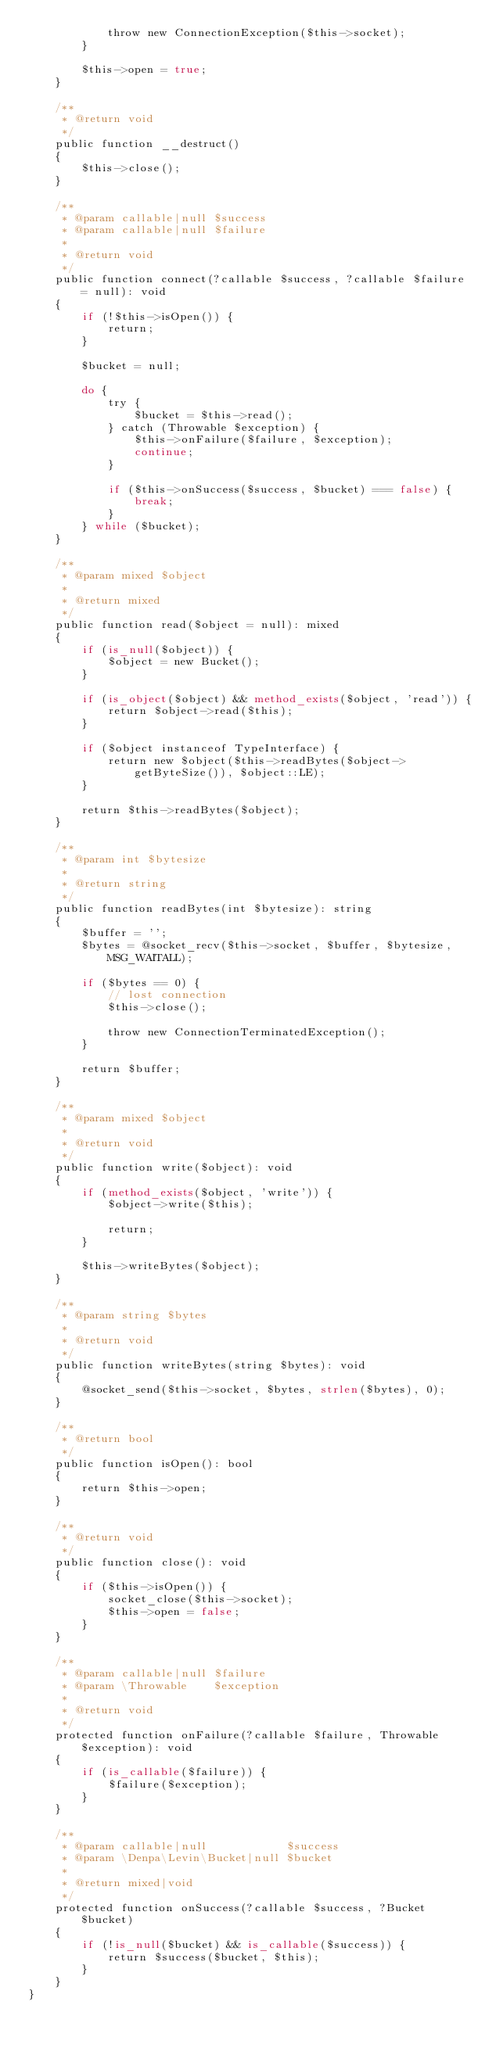<code> <loc_0><loc_0><loc_500><loc_500><_PHP_>            throw new ConnectionException($this->socket);
        }

        $this->open = true;
    }

    /**
     * @return void
     */
    public function __destruct()
    {
        $this->close();
    }

    /**
     * @param callable|null $success
     * @param callable|null $failure
     *
     * @return void
     */
    public function connect(?callable $success, ?callable $failure = null): void
    {
        if (!$this->isOpen()) {
            return;
        }

        $bucket = null;

        do {
            try {
                $bucket = $this->read();
            } catch (Throwable $exception) {
                $this->onFailure($failure, $exception);
                continue;
            }

            if ($this->onSuccess($success, $bucket) === false) {
                break;
            }
        } while ($bucket);
    }

    /**
     * @param mixed $object
     *
     * @return mixed
     */
    public function read($object = null): mixed
    {
        if (is_null($object)) {
            $object = new Bucket();
        }

        if (is_object($object) && method_exists($object, 'read')) {
            return $object->read($this);
        }

        if ($object instanceof TypeInterface) {
            return new $object($this->readBytes($object->getByteSize()), $object::LE);
        }

        return $this->readBytes($object);
    }

    /**
     * @param int $bytesize
     *
     * @return string
     */
    public function readBytes(int $bytesize): string
    {
        $buffer = '';
        $bytes = @socket_recv($this->socket, $buffer, $bytesize, MSG_WAITALL);

        if ($bytes == 0) {
            // lost connection
            $this->close();

            throw new ConnectionTerminatedException();
        }

        return $buffer;
    }

    /**
     * @param mixed $object
     *
     * @return void
     */
    public function write($object): void
    {
        if (method_exists($object, 'write')) {
            $object->write($this);

            return;
        }

        $this->writeBytes($object);
    }

    /**
     * @param string $bytes
     *
     * @return void
     */
    public function writeBytes(string $bytes): void
    {
        @socket_send($this->socket, $bytes, strlen($bytes), 0);
    }

    /**
     * @return bool
     */
    public function isOpen(): bool
    {
        return $this->open;
    }

    /**
     * @return void
     */
    public function close(): void
    {
        if ($this->isOpen()) {
            socket_close($this->socket);
            $this->open = false;
        }
    }

    /**
     * @param callable|null $failure
     * @param \Throwable    $exception
     *
     * @return void
     */
    protected function onFailure(?callable $failure, Throwable $exception): void
    {
        if (is_callable($failure)) {
            $failure($exception);
        }
    }

    /**
     * @param callable|null            $success
     * @param \Denpa\Levin\Bucket|null $bucket
     *
     * @return mixed|void
     */
    protected function onSuccess(?callable $success, ?Bucket $bucket)
    {
        if (!is_null($bucket) && is_callable($success)) {
            return $success($bucket, $this);
        }
    }
}
</code> 